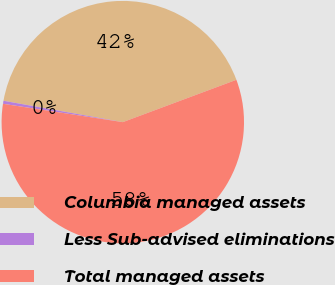<chart> <loc_0><loc_0><loc_500><loc_500><pie_chart><fcel>Columbia managed assets<fcel>Less Sub-advised eliminations<fcel>Total managed assets<nl><fcel>41.5%<fcel>0.4%<fcel>58.09%<nl></chart> 